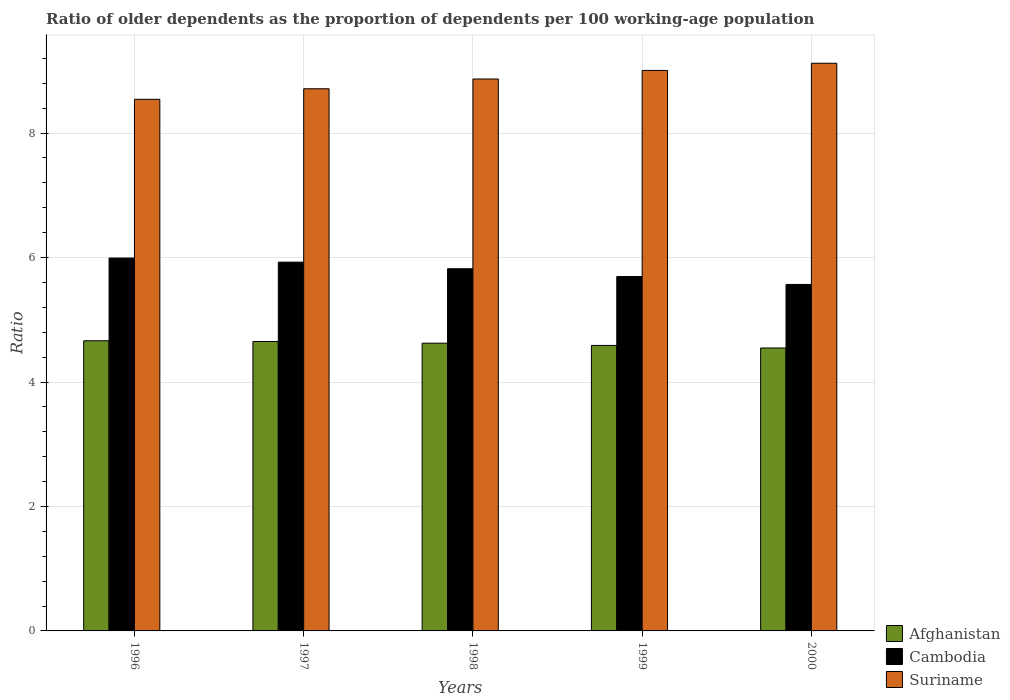Are the number of bars per tick equal to the number of legend labels?
Provide a short and direct response. Yes. How many bars are there on the 4th tick from the left?
Make the answer very short. 3. How many bars are there on the 4th tick from the right?
Keep it short and to the point. 3. What is the label of the 2nd group of bars from the left?
Provide a short and direct response. 1997. What is the age dependency ratio(old) in Suriname in 1998?
Provide a short and direct response. 8.87. Across all years, what is the maximum age dependency ratio(old) in Afghanistan?
Make the answer very short. 4.66. Across all years, what is the minimum age dependency ratio(old) in Afghanistan?
Your response must be concise. 4.55. What is the total age dependency ratio(old) in Suriname in the graph?
Make the answer very short. 44.25. What is the difference between the age dependency ratio(old) in Cambodia in 1996 and that in 1997?
Provide a succinct answer. 0.07. What is the difference between the age dependency ratio(old) in Afghanistan in 1997 and the age dependency ratio(old) in Suriname in 1996?
Your response must be concise. -3.89. What is the average age dependency ratio(old) in Afghanistan per year?
Offer a very short reply. 4.61. In the year 1997, what is the difference between the age dependency ratio(old) in Afghanistan and age dependency ratio(old) in Suriname?
Your answer should be compact. -4.06. What is the ratio of the age dependency ratio(old) in Afghanistan in 1998 to that in 2000?
Provide a short and direct response. 1.02. Is the age dependency ratio(old) in Cambodia in 1997 less than that in 1998?
Offer a terse response. No. What is the difference between the highest and the second highest age dependency ratio(old) in Afghanistan?
Make the answer very short. 0.01. What is the difference between the highest and the lowest age dependency ratio(old) in Suriname?
Provide a succinct answer. 0.58. Is the sum of the age dependency ratio(old) in Afghanistan in 1996 and 1997 greater than the maximum age dependency ratio(old) in Cambodia across all years?
Provide a short and direct response. Yes. What does the 1st bar from the left in 1997 represents?
Give a very brief answer. Afghanistan. What does the 2nd bar from the right in 1999 represents?
Give a very brief answer. Cambodia. Is it the case that in every year, the sum of the age dependency ratio(old) in Cambodia and age dependency ratio(old) in Afghanistan is greater than the age dependency ratio(old) in Suriname?
Offer a terse response. Yes. How many bars are there?
Your answer should be compact. 15. Are all the bars in the graph horizontal?
Your answer should be very brief. No. How are the legend labels stacked?
Provide a short and direct response. Vertical. What is the title of the graph?
Provide a short and direct response. Ratio of older dependents as the proportion of dependents per 100 working-age population. Does "Chile" appear as one of the legend labels in the graph?
Offer a terse response. No. What is the label or title of the Y-axis?
Give a very brief answer. Ratio. What is the Ratio of Afghanistan in 1996?
Provide a succinct answer. 4.66. What is the Ratio in Cambodia in 1996?
Provide a succinct answer. 5.99. What is the Ratio in Suriname in 1996?
Your response must be concise. 8.54. What is the Ratio of Afghanistan in 1997?
Give a very brief answer. 4.65. What is the Ratio of Cambodia in 1997?
Keep it short and to the point. 5.93. What is the Ratio in Suriname in 1997?
Ensure brevity in your answer.  8.71. What is the Ratio in Afghanistan in 1998?
Offer a very short reply. 4.62. What is the Ratio in Cambodia in 1998?
Keep it short and to the point. 5.82. What is the Ratio of Suriname in 1998?
Your response must be concise. 8.87. What is the Ratio in Afghanistan in 1999?
Provide a succinct answer. 4.59. What is the Ratio of Cambodia in 1999?
Your response must be concise. 5.7. What is the Ratio in Suriname in 1999?
Give a very brief answer. 9.01. What is the Ratio of Afghanistan in 2000?
Make the answer very short. 4.55. What is the Ratio in Cambodia in 2000?
Keep it short and to the point. 5.57. What is the Ratio of Suriname in 2000?
Provide a short and direct response. 9.12. Across all years, what is the maximum Ratio in Afghanistan?
Your response must be concise. 4.66. Across all years, what is the maximum Ratio in Cambodia?
Provide a short and direct response. 5.99. Across all years, what is the maximum Ratio of Suriname?
Provide a succinct answer. 9.12. Across all years, what is the minimum Ratio in Afghanistan?
Offer a terse response. 4.55. Across all years, what is the minimum Ratio of Cambodia?
Ensure brevity in your answer.  5.57. Across all years, what is the minimum Ratio of Suriname?
Keep it short and to the point. 8.54. What is the total Ratio of Afghanistan in the graph?
Offer a terse response. 23.07. What is the total Ratio of Cambodia in the graph?
Ensure brevity in your answer.  29. What is the total Ratio in Suriname in the graph?
Provide a succinct answer. 44.25. What is the difference between the Ratio in Afghanistan in 1996 and that in 1997?
Give a very brief answer. 0.01. What is the difference between the Ratio in Cambodia in 1996 and that in 1997?
Provide a short and direct response. 0.07. What is the difference between the Ratio in Suriname in 1996 and that in 1997?
Make the answer very short. -0.17. What is the difference between the Ratio in Afghanistan in 1996 and that in 1998?
Provide a succinct answer. 0.04. What is the difference between the Ratio in Cambodia in 1996 and that in 1998?
Your answer should be compact. 0.17. What is the difference between the Ratio in Suriname in 1996 and that in 1998?
Keep it short and to the point. -0.33. What is the difference between the Ratio in Afghanistan in 1996 and that in 1999?
Offer a very short reply. 0.07. What is the difference between the Ratio of Cambodia in 1996 and that in 1999?
Your response must be concise. 0.3. What is the difference between the Ratio in Suriname in 1996 and that in 1999?
Provide a short and direct response. -0.46. What is the difference between the Ratio of Afghanistan in 1996 and that in 2000?
Your answer should be very brief. 0.12. What is the difference between the Ratio of Cambodia in 1996 and that in 2000?
Provide a succinct answer. 0.42. What is the difference between the Ratio in Suriname in 1996 and that in 2000?
Offer a very short reply. -0.58. What is the difference between the Ratio in Afghanistan in 1997 and that in 1998?
Offer a very short reply. 0.03. What is the difference between the Ratio in Cambodia in 1997 and that in 1998?
Ensure brevity in your answer.  0.11. What is the difference between the Ratio in Suriname in 1997 and that in 1998?
Offer a terse response. -0.16. What is the difference between the Ratio in Afghanistan in 1997 and that in 1999?
Offer a terse response. 0.06. What is the difference between the Ratio in Cambodia in 1997 and that in 1999?
Your answer should be very brief. 0.23. What is the difference between the Ratio of Suriname in 1997 and that in 1999?
Your answer should be compact. -0.29. What is the difference between the Ratio in Afghanistan in 1997 and that in 2000?
Keep it short and to the point. 0.1. What is the difference between the Ratio in Cambodia in 1997 and that in 2000?
Your response must be concise. 0.36. What is the difference between the Ratio in Suriname in 1997 and that in 2000?
Offer a very short reply. -0.41. What is the difference between the Ratio of Afghanistan in 1998 and that in 1999?
Your answer should be very brief. 0.04. What is the difference between the Ratio in Cambodia in 1998 and that in 1999?
Your answer should be very brief. 0.12. What is the difference between the Ratio of Suriname in 1998 and that in 1999?
Offer a terse response. -0.14. What is the difference between the Ratio of Afghanistan in 1998 and that in 2000?
Your response must be concise. 0.08. What is the difference between the Ratio in Cambodia in 1998 and that in 2000?
Make the answer very short. 0.25. What is the difference between the Ratio in Suriname in 1998 and that in 2000?
Ensure brevity in your answer.  -0.25. What is the difference between the Ratio of Afghanistan in 1999 and that in 2000?
Your answer should be very brief. 0.04. What is the difference between the Ratio in Cambodia in 1999 and that in 2000?
Provide a succinct answer. 0.13. What is the difference between the Ratio in Suriname in 1999 and that in 2000?
Offer a very short reply. -0.12. What is the difference between the Ratio of Afghanistan in 1996 and the Ratio of Cambodia in 1997?
Your answer should be compact. -1.26. What is the difference between the Ratio in Afghanistan in 1996 and the Ratio in Suriname in 1997?
Your answer should be very brief. -4.05. What is the difference between the Ratio of Cambodia in 1996 and the Ratio of Suriname in 1997?
Offer a very short reply. -2.72. What is the difference between the Ratio in Afghanistan in 1996 and the Ratio in Cambodia in 1998?
Provide a succinct answer. -1.16. What is the difference between the Ratio of Afghanistan in 1996 and the Ratio of Suriname in 1998?
Provide a succinct answer. -4.21. What is the difference between the Ratio of Cambodia in 1996 and the Ratio of Suriname in 1998?
Your answer should be very brief. -2.88. What is the difference between the Ratio of Afghanistan in 1996 and the Ratio of Cambodia in 1999?
Provide a short and direct response. -1.03. What is the difference between the Ratio in Afghanistan in 1996 and the Ratio in Suriname in 1999?
Your response must be concise. -4.34. What is the difference between the Ratio of Cambodia in 1996 and the Ratio of Suriname in 1999?
Provide a succinct answer. -3.01. What is the difference between the Ratio of Afghanistan in 1996 and the Ratio of Cambodia in 2000?
Offer a terse response. -0.91. What is the difference between the Ratio of Afghanistan in 1996 and the Ratio of Suriname in 2000?
Offer a very short reply. -4.46. What is the difference between the Ratio of Cambodia in 1996 and the Ratio of Suriname in 2000?
Your answer should be compact. -3.13. What is the difference between the Ratio of Afghanistan in 1997 and the Ratio of Cambodia in 1998?
Offer a terse response. -1.17. What is the difference between the Ratio of Afghanistan in 1997 and the Ratio of Suriname in 1998?
Offer a very short reply. -4.22. What is the difference between the Ratio of Cambodia in 1997 and the Ratio of Suriname in 1998?
Offer a very short reply. -2.94. What is the difference between the Ratio in Afghanistan in 1997 and the Ratio in Cambodia in 1999?
Offer a terse response. -1.04. What is the difference between the Ratio in Afghanistan in 1997 and the Ratio in Suriname in 1999?
Your answer should be compact. -4.36. What is the difference between the Ratio of Cambodia in 1997 and the Ratio of Suriname in 1999?
Provide a succinct answer. -3.08. What is the difference between the Ratio of Afghanistan in 1997 and the Ratio of Cambodia in 2000?
Provide a succinct answer. -0.92. What is the difference between the Ratio in Afghanistan in 1997 and the Ratio in Suriname in 2000?
Offer a very short reply. -4.47. What is the difference between the Ratio in Cambodia in 1997 and the Ratio in Suriname in 2000?
Offer a very short reply. -3.2. What is the difference between the Ratio in Afghanistan in 1998 and the Ratio in Cambodia in 1999?
Ensure brevity in your answer.  -1.07. What is the difference between the Ratio in Afghanistan in 1998 and the Ratio in Suriname in 1999?
Your answer should be compact. -4.38. What is the difference between the Ratio of Cambodia in 1998 and the Ratio of Suriname in 1999?
Provide a succinct answer. -3.19. What is the difference between the Ratio in Afghanistan in 1998 and the Ratio in Cambodia in 2000?
Your answer should be compact. -0.94. What is the difference between the Ratio of Afghanistan in 1998 and the Ratio of Suriname in 2000?
Keep it short and to the point. -4.5. What is the difference between the Ratio of Cambodia in 1998 and the Ratio of Suriname in 2000?
Give a very brief answer. -3.3. What is the difference between the Ratio in Afghanistan in 1999 and the Ratio in Cambodia in 2000?
Provide a succinct answer. -0.98. What is the difference between the Ratio of Afghanistan in 1999 and the Ratio of Suriname in 2000?
Give a very brief answer. -4.53. What is the difference between the Ratio in Cambodia in 1999 and the Ratio in Suriname in 2000?
Make the answer very short. -3.43. What is the average Ratio in Afghanistan per year?
Ensure brevity in your answer.  4.61. What is the average Ratio in Cambodia per year?
Provide a short and direct response. 5.8. What is the average Ratio of Suriname per year?
Your response must be concise. 8.85. In the year 1996, what is the difference between the Ratio in Afghanistan and Ratio in Cambodia?
Give a very brief answer. -1.33. In the year 1996, what is the difference between the Ratio of Afghanistan and Ratio of Suriname?
Keep it short and to the point. -3.88. In the year 1996, what is the difference between the Ratio in Cambodia and Ratio in Suriname?
Give a very brief answer. -2.55. In the year 1997, what is the difference between the Ratio of Afghanistan and Ratio of Cambodia?
Your response must be concise. -1.28. In the year 1997, what is the difference between the Ratio of Afghanistan and Ratio of Suriname?
Offer a very short reply. -4.06. In the year 1997, what is the difference between the Ratio of Cambodia and Ratio of Suriname?
Provide a succinct answer. -2.79. In the year 1998, what is the difference between the Ratio of Afghanistan and Ratio of Cambodia?
Make the answer very short. -1.2. In the year 1998, what is the difference between the Ratio of Afghanistan and Ratio of Suriname?
Your answer should be compact. -4.25. In the year 1998, what is the difference between the Ratio in Cambodia and Ratio in Suriname?
Your response must be concise. -3.05. In the year 1999, what is the difference between the Ratio of Afghanistan and Ratio of Cambodia?
Give a very brief answer. -1.11. In the year 1999, what is the difference between the Ratio in Afghanistan and Ratio in Suriname?
Offer a terse response. -4.42. In the year 1999, what is the difference between the Ratio of Cambodia and Ratio of Suriname?
Your answer should be very brief. -3.31. In the year 2000, what is the difference between the Ratio of Afghanistan and Ratio of Cambodia?
Your answer should be very brief. -1.02. In the year 2000, what is the difference between the Ratio in Afghanistan and Ratio in Suriname?
Your response must be concise. -4.58. In the year 2000, what is the difference between the Ratio in Cambodia and Ratio in Suriname?
Keep it short and to the point. -3.55. What is the ratio of the Ratio of Afghanistan in 1996 to that in 1997?
Provide a short and direct response. 1. What is the ratio of the Ratio of Cambodia in 1996 to that in 1997?
Provide a succinct answer. 1.01. What is the ratio of the Ratio in Suriname in 1996 to that in 1997?
Your answer should be compact. 0.98. What is the ratio of the Ratio of Afghanistan in 1996 to that in 1998?
Your answer should be very brief. 1.01. What is the ratio of the Ratio in Cambodia in 1996 to that in 1998?
Make the answer very short. 1.03. What is the ratio of the Ratio in Suriname in 1996 to that in 1998?
Your response must be concise. 0.96. What is the ratio of the Ratio of Afghanistan in 1996 to that in 1999?
Your answer should be very brief. 1.02. What is the ratio of the Ratio in Cambodia in 1996 to that in 1999?
Provide a succinct answer. 1.05. What is the ratio of the Ratio in Suriname in 1996 to that in 1999?
Your response must be concise. 0.95. What is the ratio of the Ratio of Afghanistan in 1996 to that in 2000?
Give a very brief answer. 1.03. What is the ratio of the Ratio of Cambodia in 1996 to that in 2000?
Your answer should be compact. 1.08. What is the ratio of the Ratio in Suriname in 1996 to that in 2000?
Give a very brief answer. 0.94. What is the ratio of the Ratio in Cambodia in 1997 to that in 1998?
Your answer should be compact. 1.02. What is the ratio of the Ratio in Suriname in 1997 to that in 1998?
Your answer should be very brief. 0.98. What is the ratio of the Ratio of Afghanistan in 1997 to that in 1999?
Provide a succinct answer. 1.01. What is the ratio of the Ratio of Cambodia in 1997 to that in 1999?
Keep it short and to the point. 1.04. What is the ratio of the Ratio in Suriname in 1997 to that in 1999?
Keep it short and to the point. 0.97. What is the ratio of the Ratio in Afghanistan in 1997 to that in 2000?
Provide a succinct answer. 1.02. What is the ratio of the Ratio in Cambodia in 1997 to that in 2000?
Your response must be concise. 1.06. What is the ratio of the Ratio in Suriname in 1997 to that in 2000?
Make the answer very short. 0.96. What is the ratio of the Ratio in Afghanistan in 1998 to that in 1999?
Your answer should be very brief. 1.01. What is the ratio of the Ratio of Cambodia in 1998 to that in 1999?
Your response must be concise. 1.02. What is the ratio of the Ratio in Suriname in 1998 to that in 1999?
Offer a very short reply. 0.98. What is the ratio of the Ratio of Afghanistan in 1998 to that in 2000?
Offer a terse response. 1.02. What is the ratio of the Ratio in Cambodia in 1998 to that in 2000?
Provide a short and direct response. 1.05. What is the ratio of the Ratio in Suriname in 1998 to that in 2000?
Make the answer very short. 0.97. What is the ratio of the Ratio in Afghanistan in 1999 to that in 2000?
Provide a short and direct response. 1.01. What is the ratio of the Ratio of Cambodia in 1999 to that in 2000?
Offer a very short reply. 1.02. What is the ratio of the Ratio of Suriname in 1999 to that in 2000?
Make the answer very short. 0.99. What is the difference between the highest and the second highest Ratio in Afghanistan?
Keep it short and to the point. 0.01. What is the difference between the highest and the second highest Ratio of Cambodia?
Your answer should be compact. 0.07. What is the difference between the highest and the second highest Ratio of Suriname?
Provide a succinct answer. 0.12. What is the difference between the highest and the lowest Ratio of Afghanistan?
Offer a very short reply. 0.12. What is the difference between the highest and the lowest Ratio of Cambodia?
Provide a succinct answer. 0.42. What is the difference between the highest and the lowest Ratio of Suriname?
Give a very brief answer. 0.58. 